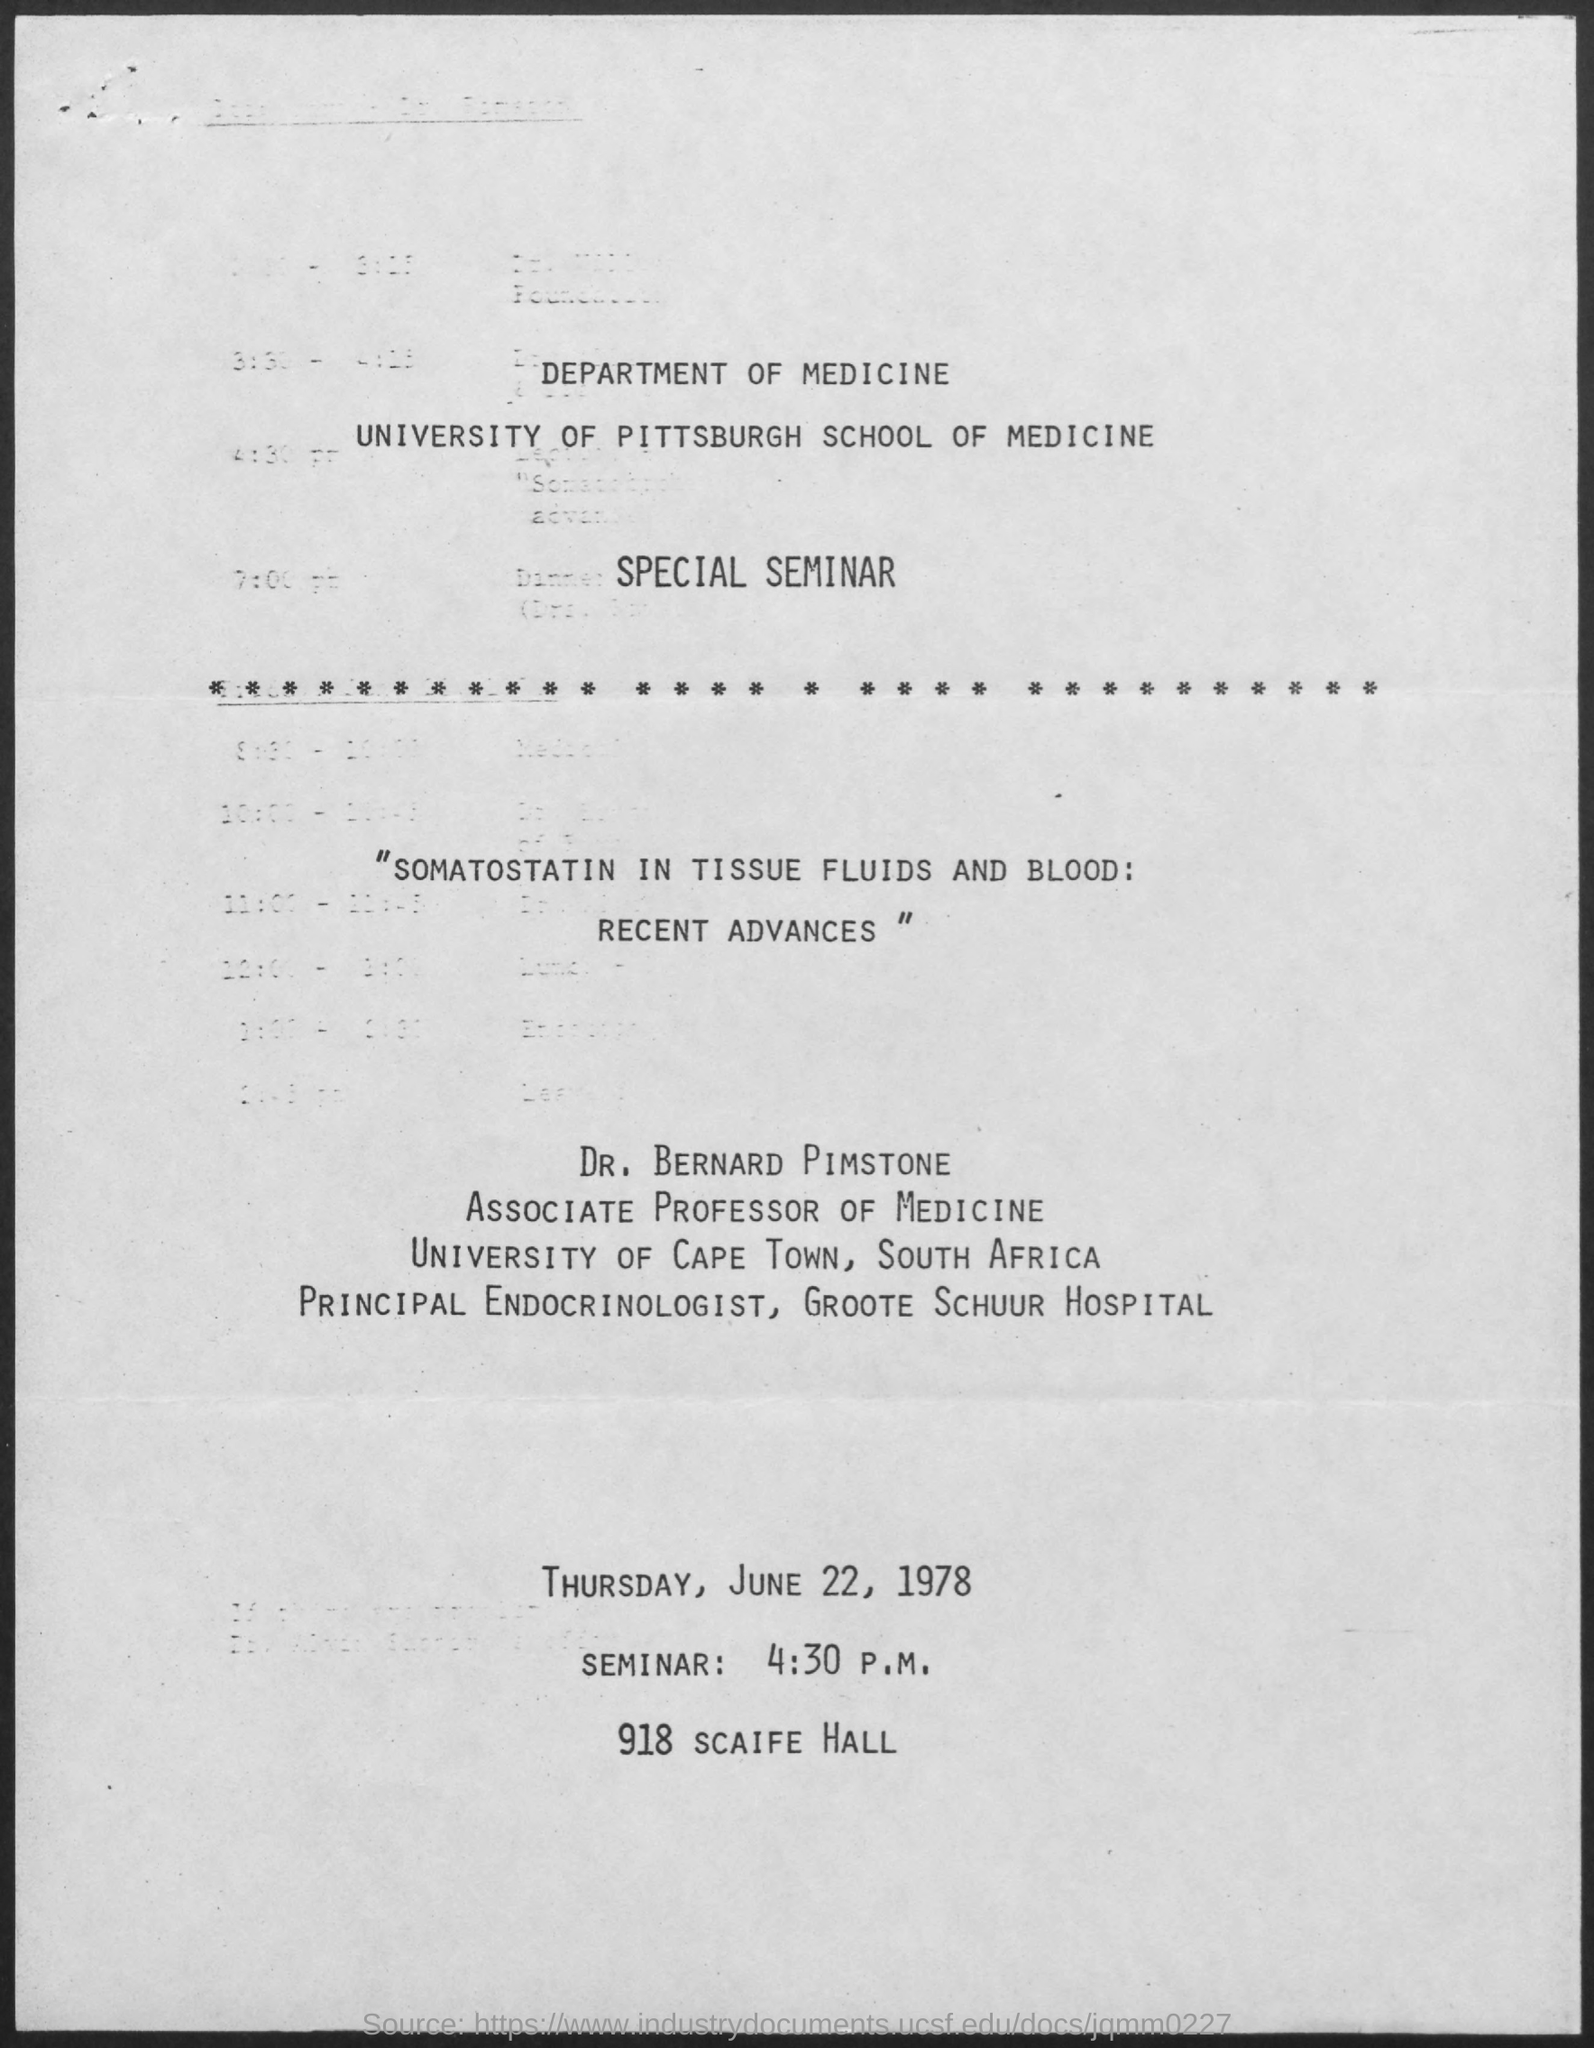Outline some significant characteristics in this image. The seminar will take place on Thursday, June 22, 1978. The seminar is being held at 918 Scaife Hall. Dr. Bernard Pimstone is the presenter of the seminar. 